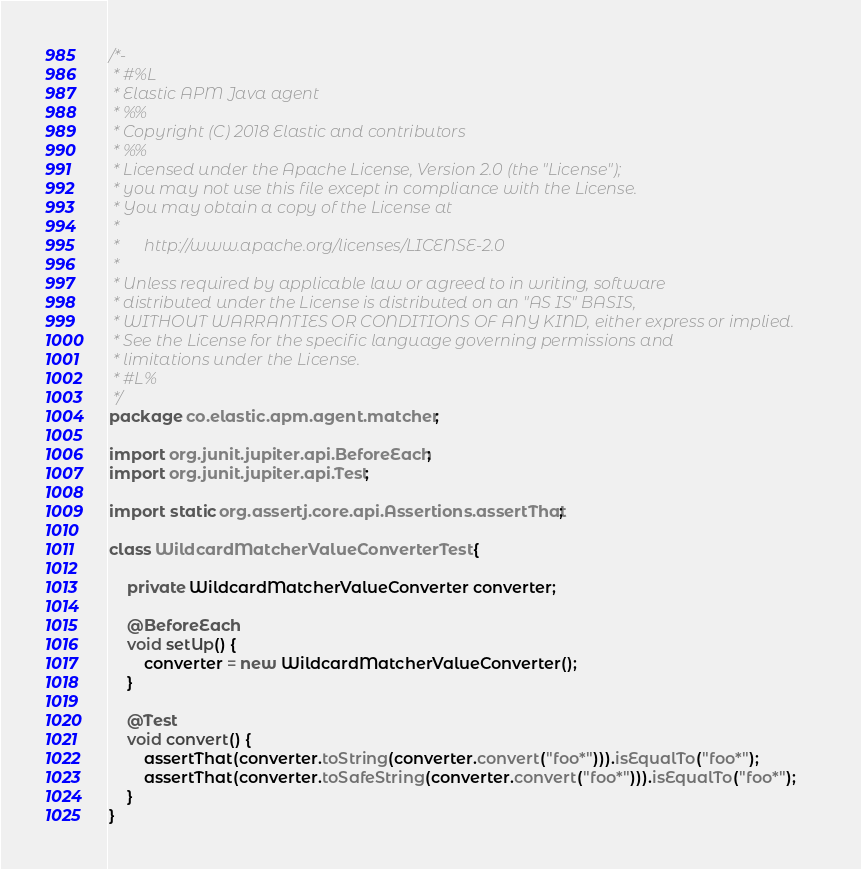Convert code to text. <code><loc_0><loc_0><loc_500><loc_500><_Java_>/*-
 * #%L
 * Elastic APM Java agent
 * %%
 * Copyright (C) 2018 Elastic and contributors
 * %%
 * Licensed under the Apache License, Version 2.0 (the "License");
 * you may not use this file except in compliance with the License.
 * You may obtain a copy of the License at
 *
 *      http://www.apache.org/licenses/LICENSE-2.0
 *
 * Unless required by applicable law or agreed to in writing, software
 * distributed under the License is distributed on an "AS IS" BASIS,
 * WITHOUT WARRANTIES OR CONDITIONS OF ANY KIND, either express or implied.
 * See the License for the specific language governing permissions and
 * limitations under the License.
 * #L%
 */
package co.elastic.apm.agent.matcher;

import org.junit.jupiter.api.BeforeEach;
import org.junit.jupiter.api.Test;

import static org.assertj.core.api.Assertions.assertThat;

class WildcardMatcherValueConverterTest {

    private WildcardMatcherValueConverter converter;

    @BeforeEach
    void setUp() {
        converter = new WildcardMatcherValueConverter();
    }

    @Test
    void convert() {
        assertThat(converter.toString(converter.convert("foo*"))).isEqualTo("foo*");
        assertThat(converter.toSafeString(converter.convert("foo*"))).isEqualTo("foo*");
    }
}
</code> 